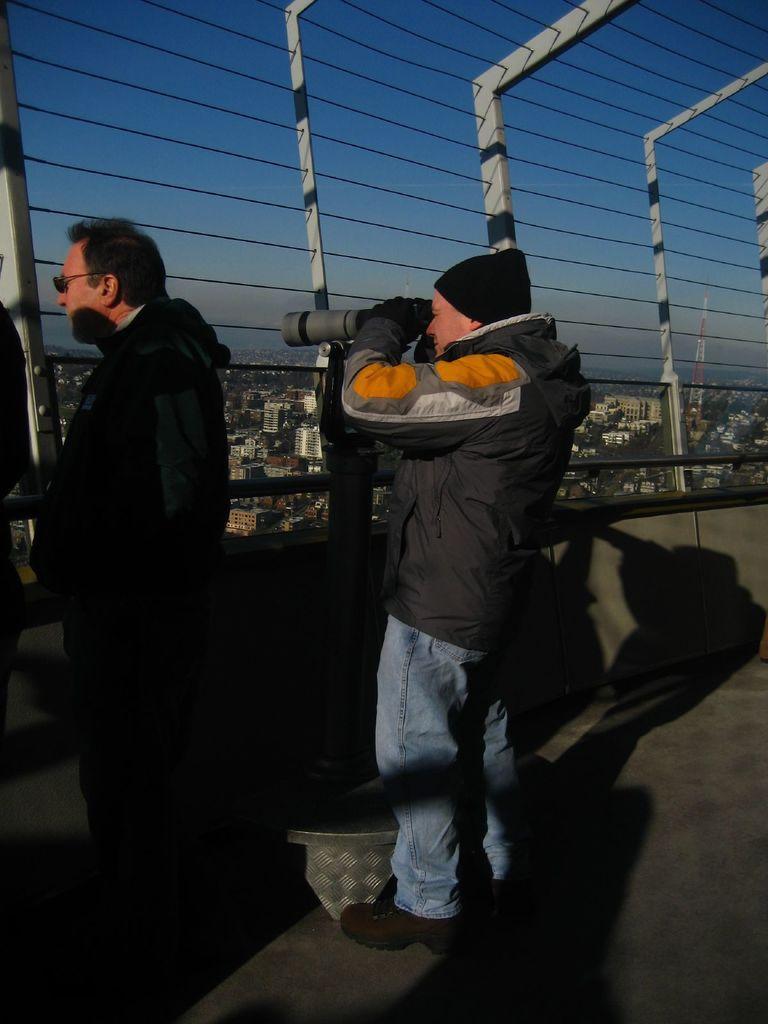How would you summarize this image in a sentence or two? This picture shows couple of men standing. We see a man wore a cap and gloves to his hands and he is holding a camera in his hands and taking picture and we see another man standing and he wore spectacles on his face and both of them wore jackets and we see buildings and a tower and metal fence and a blue sky 